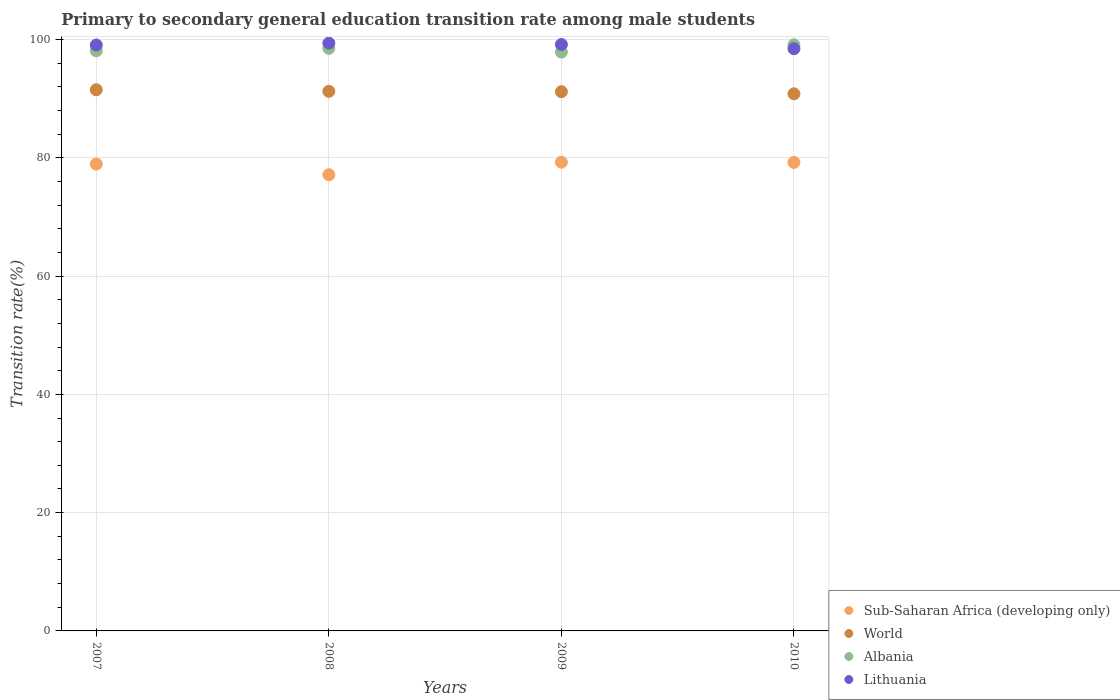What is the transition rate in World in 2010?
Provide a succinct answer. 90.81. Across all years, what is the maximum transition rate in Lithuania?
Your answer should be compact. 99.38. Across all years, what is the minimum transition rate in Sub-Saharan Africa (developing only)?
Your answer should be very brief. 77.13. In which year was the transition rate in Lithuania maximum?
Provide a succinct answer. 2008. In which year was the transition rate in Sub-Saharan Africa (developing only) minimum?
Your answer should be compact. 2008. What is the total transition rate in Sub-Saharan Africa (developing only) in the graph?
Make the answer very short. 314.53. What is the difference between the transition rate in World in 2007 and that in 2008?
Provide a short and direct response. 0.26. What is the difference between the transition rate in Lithuania in 2009 and the transition rate in Sub-Saharan Africa (developing only) in 2008?
Your answer should be compact. 22.02. What is the average transition rate in Sub-Saharan Africa (developing only) per year?
Your answer should be very brief. 78.63. In the year 2008, what is the difference between the transition rate in Sub-Saharan Africa (developing only) and transition rate in Lithuania?
Your answer should be compact. -22.25. What is the ratio of the transition rate in Albania in 2009 to that in 2010?
Provide a short and direct response. 0.99. Is the difference between the transition rate in Sub-Saharan Africa (developing only) in 2007 and 2009 greater than the difference between the transition rate in Lithuania in 2007 and 2009?
Your response must be concise. No. What is the difference between the highest and the second highest transition rate in Lithuania?
Offer a terse response. 0.23. What is the difference between the highest and the lowest transition rate in Lithuania?
Provide a short and direct response. 0.93. In how many years, is the transition rate in Albania greater than the average transition rate in Albania taken over all years?
Ensure brevity in your answer.  2. Is it the case that in every year, the sum of the transition rate in Albania and transition rate in Lithuania  is greater than the sum of transition rate in Sub-Saharan Africa (developing only) and transition rate in World?
Give a very brief answer. No. Is it the case that in every year, the sum of the transition rate in Lithuania and transition rate in Albania  is greater than the transition rate in World?
Your response must be concise. Yes. Is the transition rate in World strictly greater than the transition rate in Lithuania over the years?
Ensure brevity in your answer.  No. Are the values on the major ticks of Y-axis written in scientific E-notation?
Offer a very short reply. No. Does the graph contain any zero values?
Provide a succinct answer. No. Does the graph contain grids?
Provide a succinct answer. Yes. Where does the legend appear in the graph?
Your response must be concise. Bottom right. How are the legend labels stacked?
Offer a terse response. Vertical. What is the title of the graph?
Provide a succinct answer. Primary to secondary general education transition rate among male students. Does "Lesotho" appear as one of the legend labels in the graph?
Give a very brief answer. No. What is the label or title of the Y-axis?
Offer a terse response. Transition rate(%). What is the Transition rate(%) in Sub-Saharan Africa (developing only) in 2007?
Ensure brevity in your answer.  78.93. What is the Transition rate(%) of World in 2007?
Ensure brevity in your answer.  91.5. What is the Transition rate(%) in Albania in 2007?
Offer a terse response. 98.08. What is the Transition rate(%) of Lithuania in 2007?
Your answer should be very brief. 99.07. What is the Transition rate(%) in Sub-Saharan Africa (developing only) in 2008?
Offer a terse response. 77.13. What is the Transition rate(%) in World in 2008?
Keep it short and to the point. 91.23. What is the Transition rate(%) in Albania in 2008?
Offer a terse response. 98.5. What is the Transition rate(%) of Lithuania in 2008?
Give a very brief answer. 99.38. What is the Transition rate(%) in Sub-Saharan Africa (developing only) in 2009?
Make the answer very short. 79.25. What is the Transition rate(%) of World in 2009?
Your answer should be compact. 91.18. What is the Transition rate(%) in Albania in 2009?
Offer a terse response. 97.86. What is the Transition rate(%) of Lithuania in 2009?
Your answer should be very brief. 99.15. What is the Transition rate(%) in Sub-Saharan Africa (developing only) in 2010?
Your response must be concise. 79.22. What is the Transition rate(%) in World in 2010?
Ensure brevity in your answer.  90.81. What is the Transition rate(%) in Albania in 2010?
Offer a very short reply. 99.1. What is the Transition rate(%) in Lithuania in 2010?
Make the answer very short. 98.44. Across all years, what is the maximum Transition rate(%) in Sub-Saharan Africa (developing only)?
Offer a very short reply. 79.25. Across all years, what is the maximum Transition rate(%) of World?
Your answer should be very brief. 91.5. Across all years, what is the maximum Transition rate(%) of Albania?
Keep it short and to the point. 99.1. Across all years, what is the maximum Transition rate(%) in Lithuania?
Make the answer very short. 99.38. Across all years, what is the minimum Transition rate(%) in Sub-Saharan Africa (developing only)?
Your response must be concise. 77.13. Across all years, what is the minimum Transition rate(%) of World?
Keep it short and to the point. 90.81. Across all years, what is the minimum Transition rate(%) in Albania?
Keep it short and to the point. 97.86. Across all years, what is the minimum Transition rate(%) in Lithuania?
Your answer should be very brief. 98.44. What is the total Transition rate(%) in Sub-Saharan Africa (developing only) in the graph?
Your response must be concise. 314.52. What is the total Transition rate(%) in World in the graph?
Your answer should be compact. 364.72. What is the total Transition rate(%) in Albania in the graph?
Make the answer very short. 393.55. What is the total Transition rate(%) in Lithuania in the graph?
Your response must be concise. 396.04. What is the difference between the Transition rate(%) of Sub-Saharan Africa (developing only) in 2007 and that in 2008?
Keep it short and to the point. 1.8. What is the difference between the Transition rate(%) of World in 2007 and that in 2008?
Your response must be concise. 0.26. What is the difference between the Transition rate(%) of Albania in 2007 and that in 2008?
Make the answer very short. -0.43. What is the difference between the Transition rate(%) of Lithuania in 2007 and that in 2008?
Your answer should be compact. -0.31. What is the difference between the Transition rate(%) of Sub-Saharan Africa (developing only) in 2007 and that in 2009?
Provide a succinct answer. -0.32. What is the difference between the Transition rate(%) of World in 2007 and that in 2009?
Make the answer very short. 0.32. What is the difference between the Transition rate(%) of Albania in 2007 and that in 2009?
Your answer should be compact. 0.21. What is the difference between the Transition rate(%) in Lithuania in 2007 and that in 2009?
Provide a succinct answer. -0.08. What is the difference between the Transition rate(%) in Sub-Saharan Africa (developing only) in 2007 and that in 2010?
Give a very brief answer. -0.29. What is the difference between the Transition rate(%) of World in 2007 and that in 2010?
Give a very brief answer. 0.68. What is the difference between the Transition rate(%) of Albania in 2007 and that in 2010?
Ensure brevity in your answer.  -1.03. What is the difference between the Transition rate(%) of Lithuania in 2007 and that in 2010?
Your response must be concise. 0.62. What is the difference between the Transition rate(%) of Sub-Saharan Africa (developing only) in 2008 and that in 2009?
Give a very brief answer. -2.12. What is the difference between the Transition rate(%) of World in 2008 and that in 2009?
Offer a very short reply. 0.06. What is the difference between the Transition rate(%) of Albania in 2008 and that in 2009?
Give a very brief answer. 0.64. What is the difference between the Transition rate(%) in Lithuania in 2008 and that in 2009?
Your response must be concise. 0.23. What is the difference between the Transition rate(%) of Sub-Saharan Africa (developing only) in 2008 and that in 2010?
Give a very brief answer. -2.09. What is the difference between the Transition rate(%) of World in 2008 and that in 2010?
Ensure brevity in your answer.  0.42. What is the difference between the Transition rate(%) of Albania in 2008 and that in 2010?
Your answer should be very brief. -0.6. What is the difference between the Transition rate(%) of Lithuania in 2008 and that in 2010?
Ensure brevity in your answer.  0.93. What is the difference between the Transition rate(%) in Sub-Saharan Africa (developing only) in 2009 and that in 2010?
Provide a succinct answer. 0.03. What is the difference between the Transition rate(%) of World in 2009 and that in 2010?
Give a very brief answer. 0.36. What is the difference between the Transition rate(%) of Albania in 2009 and that in 2010?
Make the answer very short. -1.24. What is the difference between the Transition rate(%) of Lithuania in 2009 and that in 2010?
Ensure brevity in your answer.  0.71. What is the difference between the Transition rate(%) of Sub-Saharan Africa (developing only) in 2007 and the Transition rate(%) of World in 2008?
Keep it short and to the point. -12.3. What is the difference between the Transition rate(%) in Sub-Saharan Africa (developing only) in 2007 and the Transition rate(%) in Albania in 2008?
Provide a succinct answer. -19.57. What is the difference between the Transition rate(%) of Sub-Saharan Africa (developing only) in 2007 and the Transition rate(%) of Lithuania in 2008?
Your answer should be compact. -20.45. What is the difference between the Transition rate(%) of World in 2007 and the Transition rate(%) of Albania in 2008?
Your answer should be compact. -7.01. What is the difference between the Transition rate(%) of World in 2007 and the Transition rate(%) of Lithuania in 2008?
Offer a terse response. -7.88. What is the difference between the Transition rate(%) of Albania in 2007 and the Transition rate(%) of Lithuania in 2008?
Your answer should be very brief. -1.3. What is the difference between the Transition rate(%) in Sub-Saharan Africa (developing only) in 2007 and the Transition rate(%) in World in 2009?
Your answer should be compact. -12.25. What is the difference between the Transition rate(%) of Sub-Saharan Africa (developing only) in 2007 and the Transition rate(%) of Albania in 2009?
Keep it short and to the point. -18.93. What is the difference between the Transition rate(%) of Sub-Saharan Africa (developing only) in 2007 and the Transition rate(%) of Lithuania in 2009?
Ensure brevity in your answer.  -20.22. What is the difference between the Transition rate(%) in World in 2007 and the Transition rate(%) in Albania in 2009?
Your answer should be compact. -6.37. What is the difference between the Transition rate(%) in World in 2007 and the Transition rate(%) in Lithuania in 2009?
Provide a succinct answer. -7.65. What is the difference between the Transition rate(%) of Albania in 2007 and the Transition rate(%) of Lithuania in 2009?
Your answer should be very brief. -1.07. What is the difference between the Transition rate(%) of Sub-Saharan Africa (developing only) in 2007 and the Transition rate(%) of World in 2010?
Provide a succinct answer. -11.88. What is the difference between the Transition rate(%) of Sub-Saharan Africa (developing only) in 2007 and the Transition rate(%) of Albania in 2010?
Ensure brevity in your answer.  -20.17. What is the difference between the Transition rate(%) of Sub-Saharan Africa (developing only) in 2007 and the Transition rate(%) of Lithuania in 2010?
Keep it short and to the point. -19.51. What is the difference between the Transition rate(%) in World in 2007 and the Transition rate(%) in Albania in 2010?
Your response must be concise. -7.61. What is the difference between the Transition rate(%) in World in 2007 and the Transition rate(%) in Lithuania in 2010?
Give a very brief answer. -6.95. What is the difference between the Transition rate(%) in Albania in 2007 and the Transition rate(%) in Lithuania in 2010?
Your response must be concise. -0.37. What is the difference between the Transition rate(%) of Sub-Saharan Africa (developing only) in 2008 and the Transition rate(%) of World in 2009?
Give a very brief answer. -14.05. What is the difference between the Transition rate(%) in Sub-Saharan Africa (developing only) in 2008 and the Transition rate(%) in Albania in 2009?
Your answer should be compact. -20.73. What is the difference between the Transition rate(%) of Sub-Saharan Africa (developing only) in 2008 and the Transition rate(%) of Lithuania in 2009?
Make the answer very short. -22.02. What is the difference between the Transition rate(%) of World in 2008 and the Transition rate(%) of Albania in 2009?
Your answer should be very brief. -6.63. What is the difference between the Transition rate(%) of World in 2008 and the Transition rate(%) of Lithuania in 2009?
Make the answer very short. -7.92. What is the difference between the Transition rate(%) of Albania in 2008 and the Transition rate(%) of Lithuania in 2009?
Ensure brevity in your answer.  -0.65. What is the difference between the Transition rate(%) of Sub-Saharan Africa (developing only) in 2008 and the Transition rate(%) of World in 2010?
Offer a terse response. -13.68. What is the difference between the Transition rate(%) of Sub-Saharan Africa (developing only) in 2008 and the Transition rate(%) of Albania in 2010?
Make the answer very short. -21.97. What is the difference between the Transition rate(%) of Sub-Saharan Africa (developing only) in 2008 and the Transition rate(%) of Lithuania in 2010?
Ensure brevity in your answer.  -21.31. What is the difference between the Transition rate(%) of World in 2008 and the Transition rate(%) of Albania in 2010?
Offer a very short reply. -7.87. What is the difference between the Transition rate(%) in World in 2008 and the Transition rate(%) in Lithuania in 2010?
Your response must be concise. -7.21. What is the difference between the Transition rate(%) of Albania in 2008 and the Transition rate(%) of Lithuania in 2010?
Give a very brief answer. 0.06. What is the difference between the Transition rate(%) of Sub-Saharan Africa (developing only) in 2009 and the Transition rate(%) of World in 2010?
Offer a very short reply. -11.57. What is the difference between the Transition rate(%) of Sub-Saharan Africa (developing only) in 2009 and the Transition rate(%) of Albania in 2010?
Provide a succinct answer. -19.86. What is the difference between the Transition rate(%) in Sub-Saharan Africa (developing only) in 2009 and the Transition rate(%) in Lithuania in 2010?
Ensure brevity in your answer.  -19.2. What is the difference between the Transition rate(%) in World in 2009 and the Transition rate(%) in Albania in 2010?
Offer a terse response. -7.93. What is the difference between the Transition rate(%) in World in 2009 and the Transition rate(%) in Lithuania in 2010?
Your answer should be very brief. -7.27. What is the difference between the Transition rate(%) of Albania in 2009 and the Transition rate(%) of Lithuania in 2010?
Make the answer very short. -0.58. What is the average Transition rate(%) in Sub-Saharan Africa (developing only) per year?
Make the answer very short. 78.63. What is the average Transition rate(%) of World per year?
Your response must be concise. 91.18. What is the average Transition rate(%) in Albania per year?
Provide a succinct answer. 98.39. What is the average Transition rate(%) in Lithuania per year?
Your answer should be very brief. 99.01. In the year 2007, what is the difference between the Transition rate(%) of Sub-Saharan Africa (developing only) and Transition rate(%) of World?
Keep it short and to the point. -12.57. In the year 2007, what is the difference between the Transition rate(%) of Sub-Saharan Africa (developing only) and Transition rate(%) of Albania?
Give a very brief answer. -19.15. In the year 2007, what is the difference between the Transition rate(%) of Sub-Saharan Africa (developing only) and Transition rate(%) of Lithuania?
Your response must be concise. -20.14. In the year 2007, what is the difference between the Transition rate(%) of World and Transition rate(%) of Albania?
Offer a very short reply. -6.58. In the year 2007, what is the difference between the Transition rate(%) of World and Transition rate(%) of Lithuania?
Ensure brevity in your answer.  -7.57. In the year 2007, what is the difference between the Transition rate(%) in Albania and Transition rate(%) in Lithuania?
Your answer should be compact. -0.99. In the year 2008, what is the difference between the Transition rate(%) in Sub-Saharan Africa (developing only) and Transition rate(%) in World?
Your answer should be compact. -14.1. In the year 2008, what is the difference between the Transition rate(%) in Sub-Saharan Africa (developing only) and Transition rate(%) in Albania?
Provide a succinct answer. -21.37. In the year 2008, what is the difference between the Transition rate(%) in Sub-Saharan Africa (developing only) and Transition rate(%) in Lithuania?
Make the answer very short. -22.25. In the year 2008, what is the difference between the Transition rate(%) in World and Transition rate(%) in Albania?
Offer a very short reply. -7.27. In the year 2008, what is the difference between the Transition rate(%) in World and Transition rate(%) in Lithuania?
Make the answer very short. -8.15. In the year 2008, what is the difference between the Transition rate(%) in Albania and Transition rate(%) in Lithuania?
Give a very brief answer. -0.88. In the year 2009, what is the difference between the Transition rate(%) in Sub-Saharan Africa (developing only) and Transition rate(%) in World?
Provide a short and direct response. -11.93. In the year 2009, what is the difference between the Transition rate(%) of Sub-Saharan Africa (developing only) and Transition rate(%) of Albania?
Keep it short and to the point. -18.62. In the year 2009, what is the difference between the Transition rate(%) of Sub-Saharan Africa (developing only) and Transition rate(%) of Lithuania?
Make the answer very short. -19.9. In the year 2009, what is the difference between the Transition rate(%) of World and Transition rate(%) of Albania?
Keep it short and to the point. -6.69. In the year 2009, what is the difference between the Transition rate(%) of World and Transition rate(%) of Lithuania?
Keep it short and to the point. -7.97. In the year 2009, what is the difference between the Transition rate(%) of Albania and Transition rate(%) of Lithuania?
Give a very brief answer. -1.29. In the year 2010, what is the difference between the Transition rate(%) in Sub-Saharan Africa (developing only) and Transition rate(%) in World?
Your answer should be compact. -11.6. In the year 2010, what is the difference between the Transition rate(%) of Sub-Saharan Africa (developing only) and Transition rate(%) of Albania?
Make the answer very short. -19.89. In the year 2010, what is the difference between the Transition rate(%) of Sub-Saharan Africa (developing only) and Transition rate(%) of Lithuania?
Ensure brevity in your answer.  -19.23. In the year 2010, what is the difference between the Transition rate(%) of World and Transition rate(%) of Albania?
Offer a terse response. -8.29. In the year 2010, what is the difference between the Transition rate(%) in World and Transition rate(%) in Lithuania?
Give a very brief answer. -7.63. In the year 2010, what is the difference between the Transition rate(%) in Albania and Transition rate(%) in Lithuania?
Your answer should be very brief. 0.66. What is the ratio of the Transition rate(%) in Sub-Saharan Africa (developing only) in 2007 to that in 2008?
Offer a very short reply. 1.02. What is the ratio of the Transition rate(%) of World in 2007 to that in 2008?
Keep it short and to the point. 1. What is the ratio of the Transition rate(%) of World in 2007 to that in 2009?
Offer a terse response. 1. What is the ratio of the Transition rate(%) of Albania in 2007 to that in 2009?
Provide a short and direct response. 1. What is the ratio of the Transition rate(%) in World in 2007 to that in 2010?
Provide a short and direct response. 1.01. What is the ratio of the Transition rate(%) in Sub-Saharan Africa (developing only) in 2008 to that in 2009?
Offer a terse response. 0.97. What is the ratio of the Transition rate(%) of Lithuania in 2008 to that in 2009?
Provide a short and direct response. 1. What is the ratio of the Transition rate(%) of Sub-Saharan Africa (developing only) in 2008 to that in 2010?
Your answer should be very brief. 0.97. What is the ratio of the Transition rate(%) in World in 2008 to that in 2010?
Provide a short and direct response. 1. What is the ratio of the Transition rate(%) of Albania in 2008 to that in 2010?
Give a very brief answer. 0.99. What is the ratio of the Transition rate(%) of Lithuania in 2008 to that in 2010?
Give a very brief answer. 1.01. What is the ratio of the Transition rate(%) of World in 2009 to that in 2010?
Your answer should be compact. 1. What is the ratio of the Transition rate(%) of Albania in 2009 to that in 2010?
Give a very brief answer. 0.99. What is the ratio of the Transition rate(%) in Lithuania in 2009 to that in 2010?
Offer a very short reply. 1.01. What is the difference between the highest and the second highest Transition rate(%) in Sub-Saharan Africa (developing only)?
Provide a short and direct response. 0.03. What is the difference between the highest and the second highest Transition rate(%) in World?
Your answer should be very brief. 0.26. What is the difference between the highest and the second highest Transition rate(%) of Albania?
Give a very brief answer. 0.6. What is the difference between the highest and the second highest Transition rate(%) in Lithuania?
Offer a terse response. 0.23. What is the difference between the highest and the lowest Transition rate(%) in Sub-Saharan Africa (developing only)?
Give a very brief answer. 2.12. What is the difference between the highest and the lowest Transition rate(%) in World?
Keep it short and to the point. 0.68. What is the difference between the highest and the lowest Transition rate(%) in Albania?
Provide a succinct answer. 1.24. What is the difference between the highest and the lowest Transition rate(%) of Lithuania?
Make the answer very short. 0.93. 